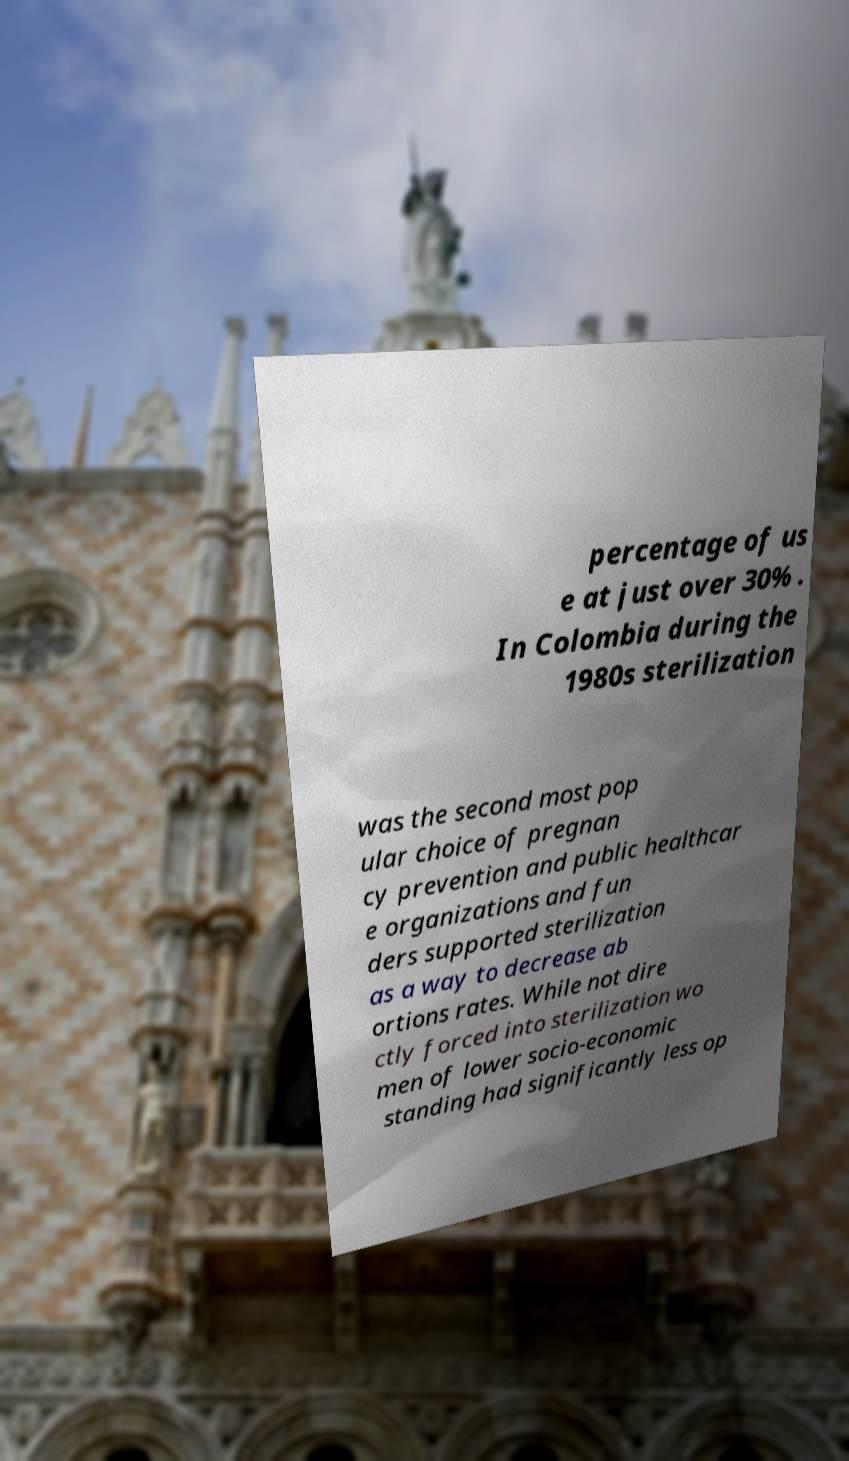Please identify and transcribe the text found in this image. percentage of us e at just over 30% . In Colombia during the 1980s sterilization was the second most pop ular choice of pregnan cy prevention and public healthcar e organizations and fun ders supported sterilization as a way to decrease ab ortions rates. While not dire ctly forced into sterilization wo men of lower socio-economic standing had significantly less op 